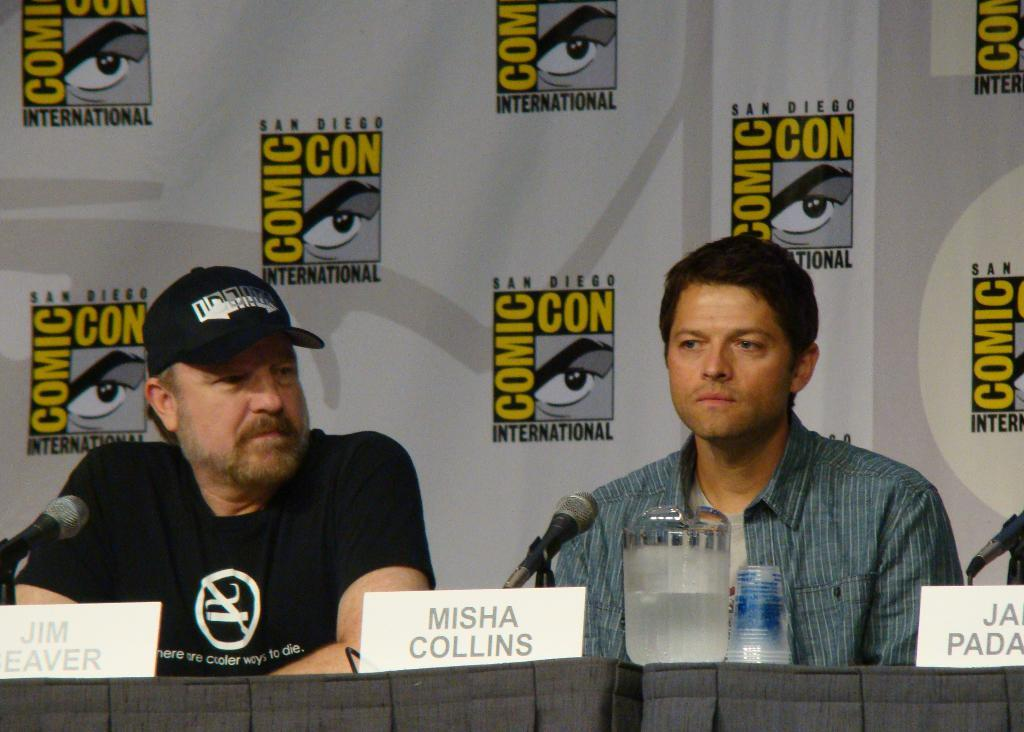<image>
Share a concise interpretation of the image provided. Two men sit being interviewed at a comic con. 